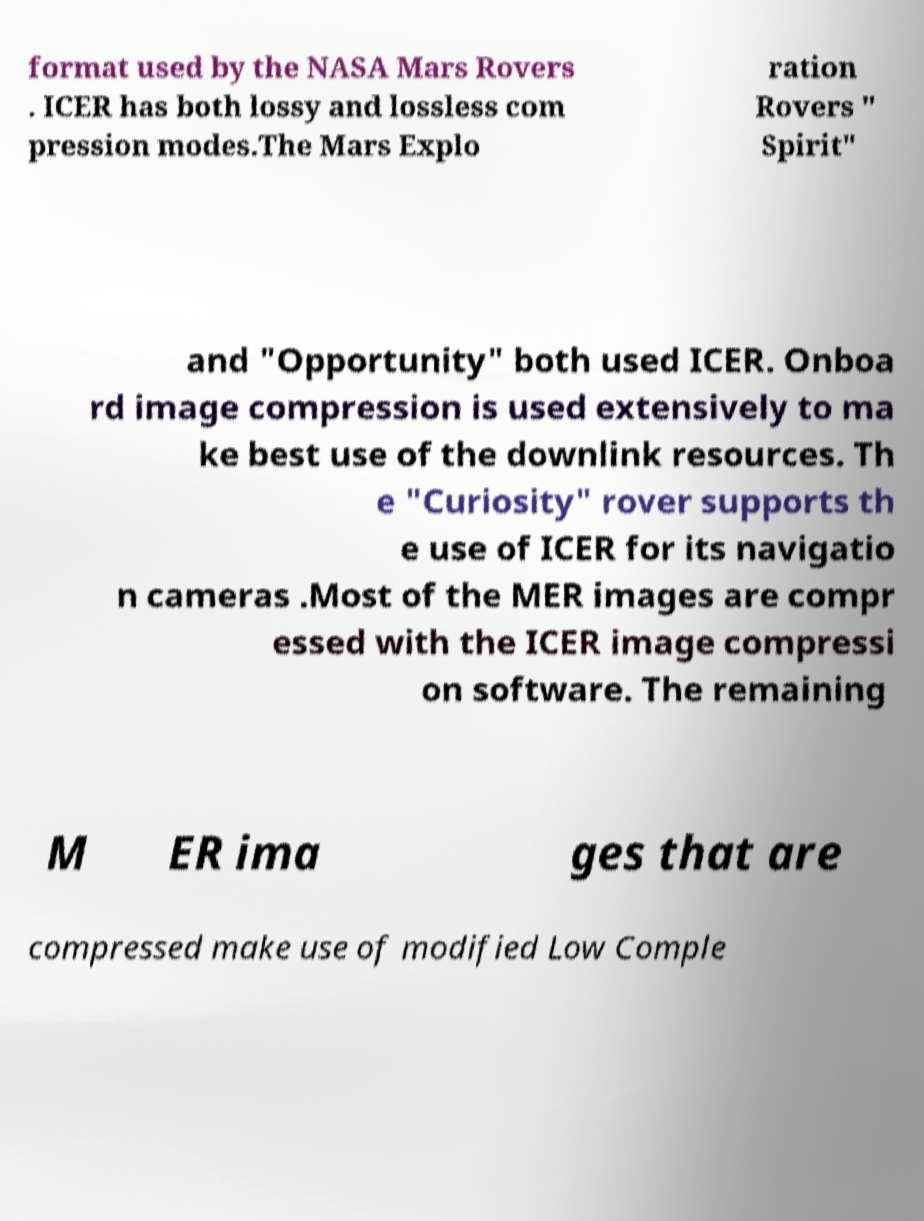Could you extract and type out the text from this image? format used by the NASA Mars Rovers . ICER has both lossy and lossless com pression modes.The Mars Explo ration Rovers " Spirit" and "Opportunity" both used ICER. Onboa rd image compression is used extensively to ma ke best use of the downlink resources. Th e "Curiosity" rover supports th e use of ICER for its navigatio n cameras .Most of the MER images are compr essed with the ICER image compressi on software. The remaining M ER ima ges that are compressed make use of modified Low Comple 